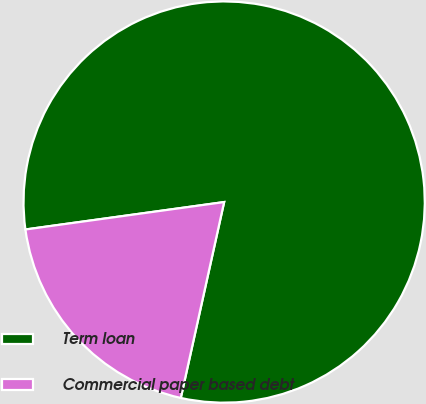<chart> <loc_0><loc_0><loc_500><loc_500><pie_chart><fcel>Term loan<fcel>Commercial paper based debt<nl><fcel>80.65%<fcel>19.35%<nl></chart> 